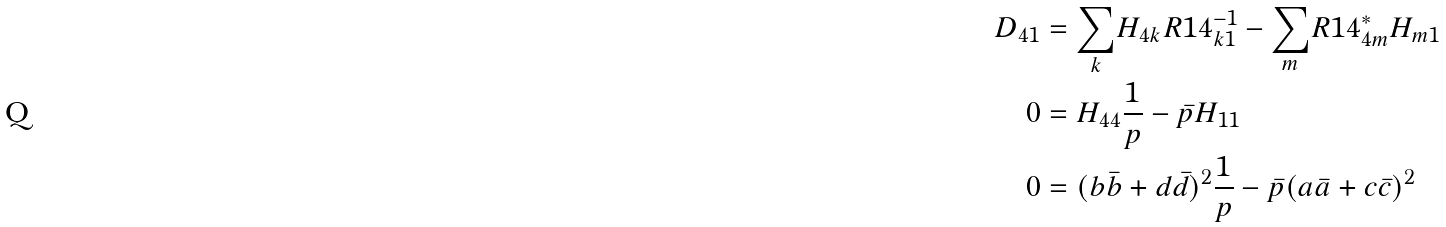Convert formula to latex. <formula><loc_0><loc_0><loc_500><loc_500>D _ { 4 1 } & = \underset { k } { \sum } H _ { 4 k } R 1 4 ^ { - 1 } _ { k 1 } - \underset { m } { \sum } R 1 4 ^ { * } _ { 4 m } H _ { m 1 } \\ 0 & = H _ { 4 4 } \frac { 1 } { p } - \bar { p } H _ { 1 1 } \\ 0 & = ( b \bar { b } + d \bar { d } ) ^ { 2 } \frac { 1 } { p } - \bar { p } ( a \bar { a } + c \bar { c } ) ^ { 2 } \\</formula> 